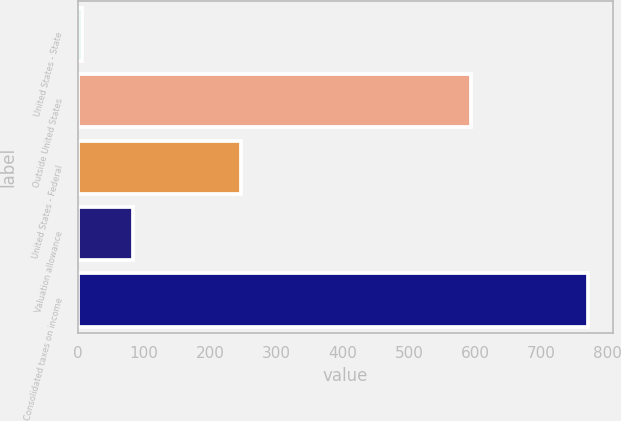<chart> <loc_0><loc_0><loc_500><loc_500><bar_chart><fcel>United States - State<fcel>Outside United States<fcel>United States - Federal<fcel>Valuation allowance<fcel>Consolidated taxes on income<nl><fcel>6<fcel>594<fcel>247<fcel>82.4<fcel>770<nl></chart> 